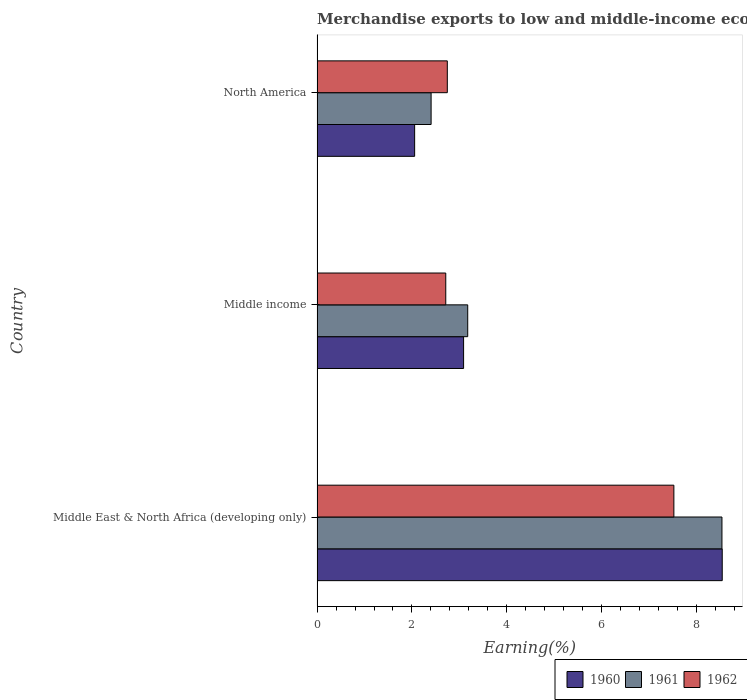How many groups of bars are there?
Keep it short and to the point. 3. Are the number of bars per tick equal to the number of legend labels?
Your answer should be very brief. Yes. Are the number of bars on each tick of the Y-axis equal?
Provide a succinct answer. Yes. How many bars are there on the 1st tick from the bottom?
Your answer should be compact. 3. In how many cases, is the number of bars for a given country not equal to the number of legend labels?
Give a very brief answer. 0. What is the percentage of amount earned from merchandise exports in 1962 in Middle income?
Offer a terse response. 2.71. Across all countries, what is the maximum percentage of amount earned from merchandise exports in 1962?
Give a very brief answer. 7.52. Across all countries, what is the minimum percentage of amount earned from merchandise exports in 1960?
Provide a short and direct response. 2.06. In which country was the percentage of amount earned from merchandise exports in 1962 maximum?
Keep it short and to the point. Middle East & North Africa (developing only). What is the total percentage of amount earned from merchandise exports in 1962 in the graph?
Give a very brief answer. 12.98. What is the difference between the percentage of amount earned from merchandise exports in 1961 in Middle income and that in North America?
Ensure brevity in your answer.  0.77. What is the difference between the percentage of amount earned from merchandise exports in 1962 in Middle income and the percentage of amount earned from merchandise exports in 1960 in North America?
Your response must be concise. 0.66. What is the average percentage of amount earned from merchandise exports in 1960 per country?
Your answer should be compact. 4.56. What is the difference between the percentage of amount earned from merchandise exports in 1960 and percentage of amount earned from merchandise exports in 1962 in Middle income?
Your answer should be very brief. 0.38. In how many countries, is the percentage of amount earned from merchandise exports in 1960 greater than 8 %?
Offer a terse response. 1. What is the ratio of the percentage of amount earned from merchandise exports in 1962 in Middle East & North Africa (developing only) to that in North America?
Your answer should be compact. 2.74. Is the percentage of amount earned from merchandise exports in 1962 in Middle East & North Africa (developing only) less than that in Middle income?
Give a very brief answer. No. Is the difference between the percentage of amount earned from merchandise exports in 1960 in Middle income and North America greater than the difference between the percentage of amount earned from merchandise exports in 1962 in Middle income and North America?
Offer a very short reply. Yes. What is the difference between the highest and the second highest percentage of amount earned from merchandise exports in 1961?
Offer a terse response. 5.36. What is the difference between the highest and the lowest percentage of amount earned from merchandise exports in 1962?
Your answer should be very brief. 4.81. In how many countries, is the percentage of amount earned from merchandise exports in 1961 greater than the average percentage of amount earned from merchandise exports in 1961 taken over all countries?
Give a very brief answer. 1. What does the 3rd bar from the bottom in Middle East & North Africa (developing only) represents?
Offer a terse response. 1962. Is it the case that in every country, the sum of the percentage of amount earned from merchandise exports in 1962 and percentage of amount earned from merchandise exports in 1960 is greater than the percentage of amount earned from merchandise exports in 1961?
Your answer should be compact. Yes. How many bars are there?
Offer a very short reply. 9. Are the values on the major ticks of X-axis written in scientific E-notation?
Keep it short and to the point. No. Does the graph contain grids?
Your response must be concise. No. How many legend labels are there?
Give a very brief answer. 3. How are the legend labels stacked?
Offer a terse response. Horizontal. What is the title of the graph?
Offer a terse response. Merchandise exports to low and middle-income economies in the Arab World. What is the label or title of the X-axis?
Your answer should be compact. Earning(%). What is the label or title of the Y-axis?
Offer a very short reply. Country. What is the Earning(%) of 1960 in Middle East & North Africa (developing only)?
Your answer should be compact. 8.54. What is the Earning(%) of 1961 in Middle East & North Africa (developing only)?
Offer a very short reply. 8.53. What is the Earning(%) of 1962 in Middle East & North Africa (developing only)?
Your answer should be compact. 7.52. What is the Earning(%) of 1960 in Middle income?
Your response must be concise. 3.09. What is the Earning(%) in 1961 in Middle income?
Keep it short and to the point. 3.17. What is the Earning(%) in 1962 in Middle income?
Offer a very short reply. 2.71. What is the Earning(%) of 1960 in North America?
Keep it short and to the point. 2.06. What is the Earning(%) of 1961 in North America?
Your answer should be compact. 2.4. What is the Earning(%) of 1962 in North America?
Ensure brevity in your answer.  2.74. Across all countries, what is the maximum Earning(%) of 1960?
Your answer should be very brief. 8.54. Across all countries, what is the maximum Earning(%) in 1961?
Your answer should be very brief. 8.53. Across all countries, what is the maximum Earning(%) in 1962?
Offer a terse response. 7.52. Across all countries, what is the minimum Earning(%) in 1960?
Provide a succinct answer. 2.06. Across all countries, what is the minimum Earning(%) of 1961?
Ensure brevity in your answer.  2.4. Across all countries, what is the minimum Earning(%) of 1962?
Make the answer very short. 2.71. What is the total Earning(%) in 1960 in the graph?
Ensure brevity in your answer.  13.68. What is the total Earning(%) in 1961 in the graph?
Provide a short and direct response. 14.11. What is the total Earning(%) in 1962 in the graph?
Ensure brevity in your answer.  12.98. What is the difference between the Earning(%) of 1960 in Middle East & North Africa (developing only) and that in Middle income?
Provide a short and direct response. 5.45. What is the difference between the Earning(%) of 1961 in Middle East & North Africa (developing only) and that in Middle income?
Offer a very short reply. 5.36. What is the difference between the Earning(%) of 1962 in Middle East & North Africa (developing only) and that in Middle income?
Your answer should be compact. 4.81. What is the difference between the Earning(%) in 1960 in Middle East & North Africa (developing only) and that in North America?
Your answer should be compact. 6.48. What is the difference between the Earning(%) of 1961 in Middle East & North Africa (developing only) and that in North America?
Your answer should be very brief. 6.13. What is the difference between the Earning(%) of 1962 in Middle East & North Africa (developing only) and that in North America?
Offer a very short reply. 4.77. What is the difference between the Earning(%) of 1960 in Middle income and that in North America?
Provide a succinct answer. 1.03. What is the difference between the Earning(%) of 1961 in Middle income and that in North America?
Offer a terse response. 0.77. What is the difference between the Earning(%) in 1962 in Middle income and that in North America?
Ensure brevity in your answer.  -0.03. What is the difference between the Earning(%) of 1960 in Middle East & North Africa (developing only) and the Earning(%) of 1961 in Middle income?
Provide a succinct answer. 5.36. What is the difference between the Earning(%) in 1960 in Middle East & North Africa (developing only) and the Earning(%) in 1962 in Middle income?
Ensure brevity in your answer.  5.83. What is the difference between the Earning(%) in 1961 in Middle East & North Africa (developing only) and the Earning(%) in 1962 in Middle income?
Make the answer very short. 5.82. What is the difference between the Earning(%) of 1960 in Middle East & North Africa (developing only) and the Earning(%) of 1961 in North America?
Offer a very short reply. 6.13. What is the difference between the Earning(%) of 1960 in Middle East & North Africa (developing only) and the Earning(%) of 1962 in North America?
Offer a very short reply. 5.79. What is the difference between the Earning(%) of 1961 in Middle East & North Africa (developing only) and the Earning(%) of 1962 in North America?
Your response must be concise. 5.79. What is the difference between the Earning(%) of 1960 in Middle income and the Earning(%) of 1961 in North America?
Provide a short and direct response. 0.68. What is the difference between the Earning(%) in 1960 in Middle income and the Earning(%) in 1962 in North America?
Provide a short and direct response. 0.34. What is the difference between the Earning(%) in 1961 in Middle income and the Earning(%) in 1962 in North America?
Make the answer very short. 0.43. What is the average Earning(%) in 1960 per country?
Make the answer very short. 4.56. What is the average Earning(%) in 1961 per country?
Ensure brevity in your answer.  4.7. What is the average Earning(%) in 1962 per country?
Provide a short and direct response. 4.33. What is the difference between the Earning(%) of 1960 and Earning(%) of 1961 in Middle East & North Africa (developing only)?
Provide a short and direct response. 0.01. What is the difference between the Earning(%) in 1960 and Earning(%) in 1962 in Middle East & North Africa (developing only)?
Ensure brevity in your answer.  1.02. What is the difference between the Earning(%) in 1961 and Earning(%) in 1962 in Middle East & North Africa (developing only)?
Give a very brief answer. 1.01. What is the difference between the Earning(%) in 1960 and Earning(%) in 1961 in Middle income?
Your response must be concise. -0.09. What is the difference between the Earning(%) in 1960 and Earning(%) in 1962 in Middle income?
Offer a very short reply. 0.38. What is the difference between the Earning(%) of 1961 and Earning(%) of 1962 in Middle income?
Your answer should be compact. 0.46. What is the difference between the Earning(%) in 1960 and Earning(%) in 1961 in North America?
Provide a succinct answer. -0.35. What is the difference between the Earning(%) of 1960 and Earning(%) of 1962 in North America?
Offer a very short reply. -0.69. What is the difference between the Earning(%) of 1961 and Earning(%) of 1962 in North America?
Your answer should be very brief. -0.34. What is the ratio of the Earning(%) of 1960 in Middle East & North Africa (developing only) to that in Middle income?
Give a very brief answer. 2.76. What is the ratio of the Earning(%) in 1961 in Middle East & North Africa (developing only) to that in Middle income?
Provide a succinct answer. 2.69. What is the ratio of the Earning(%) of 1962 in Middle East & North Africa (developing only) to that in Middle income?
Make the answer very short. 2.77. What is the ratio of the Earning(%) in 1960 in Middle East & North Africa (developing only) to that in North America?
Make the answer very short. 4.15. What is the ratio of the Earning(%) of 1961 in Middle East & North Africa (developing only) to that in North America?
Make the answer very short. 3.55. What is the ratio of the Earning(%) of 1962 in Middle East & North Africa (developing only) to that in North America?
Ensure brevity in your answer.  2.74. What is the ratio of the Earning(%) of 1960 in Middle income to that in North America?
Provide a succinct answer. 1.5. What is the ratio of the Earning(%) of 1961 in Middle income to that in North America?
Provide a short and direct response. 1.32. What is the ratio of the Earning(%) of 1962 in Middle income to that in North America?
Give a very brief answer. 0.99. What is the difference between the highest and the second highest Earning(%) of 1960?
Give a very brief answer. 5.45. What is the difference between the highest and the second highest Earning(%) of 1961?
Your answer should be compact. 5.36. What is the difference between the highest and the second highest Earning(%) of 1962?
Give a very brief answer. 4.77. What is the difference between the highest and the lowest Earning(%) of 1960?
Your response must be concise. 6.48. What is the difference between the highest and the lowest Earning(%) of 1961?
Make the answer very short. 6.13. What is the difference between the highest and the lowest Earning(%) in 1962?
Your answer should be very brief. 4.81. 